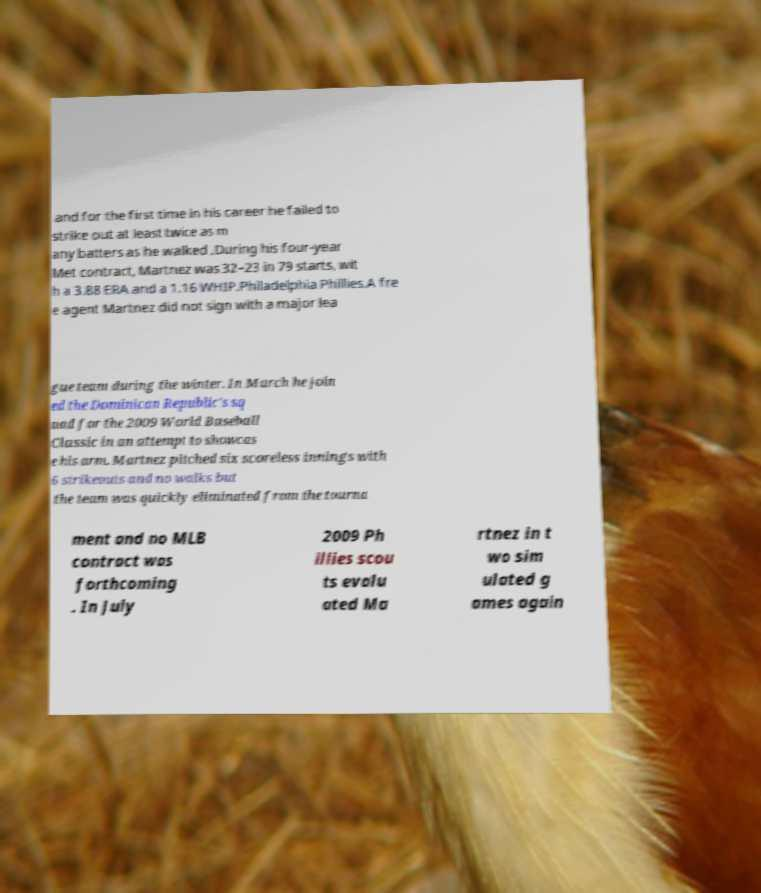For documentation purposes, I need the text within this image transcribed. Could you provide that? and for the first time in his career he failed to strike out at least twice as m any batters as he walked .During his four-year Met contract, Martnez was 32–23 in 79 starts, wit h a 3.88 ERA and a 1.16 WHIP.Philadelphia Phillies.A fre e agent Martnez did not sign with a major lea gue team during the winter. In March he join ed the Dominican Republic's sq uad for the 2009 World Baseball Classic in an attempt to showcas e his arm. Martnez pitched six scoreless innings with 6 strikeouts and no walks but the team was quickly eliminated from the tourna ment and no MLB contract was forthcoming . In July 2009 Ph illies scou ts evalu ated Ma rtnez in t wo sim ulated g ames again 